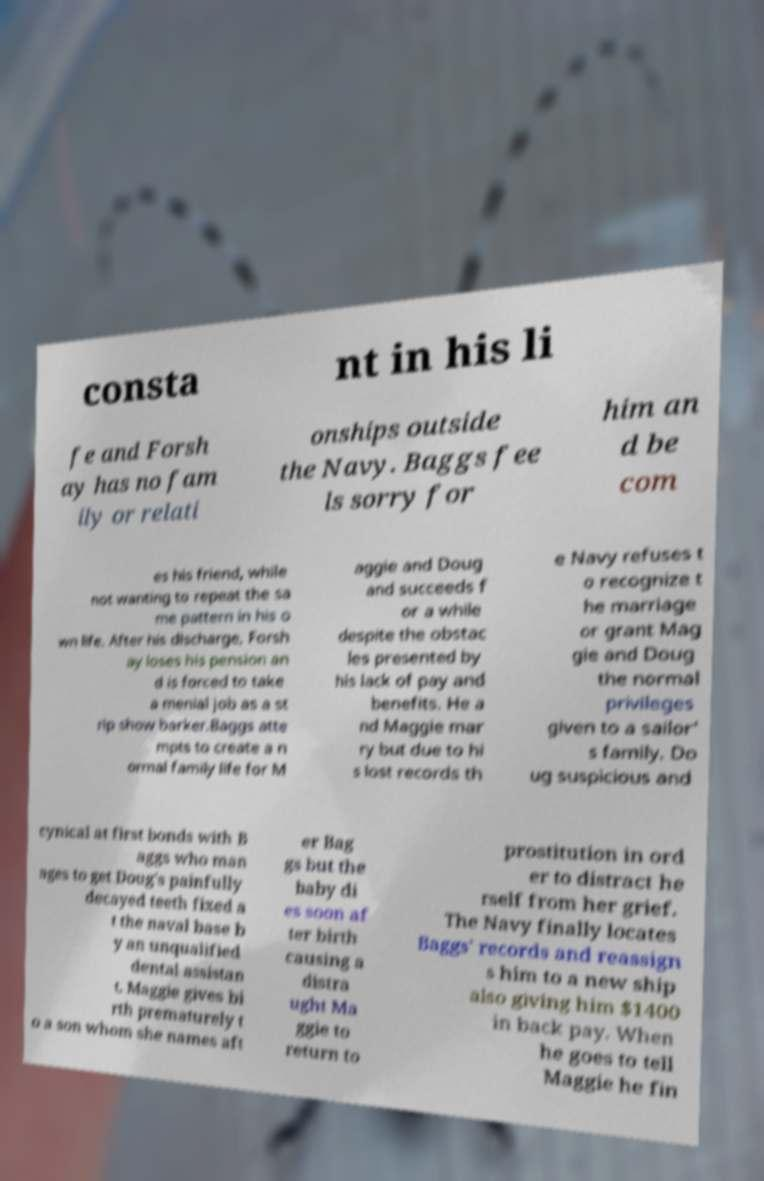Can you read and provide the text displayed in the image?This photo seems to have some interesting text. Can you extract and type it out for me? consta nt in his li fe and Forsh ay has no fam ily or relati onships outside the Navy. Baggs fee ls sorry for him an d be com es his friend, while not wanting to repeat the sa me pattern in his o wn life. After his discharge, Forsh ay loses his pension an d is forced to take a menial job as a st rip show barker.Baggs atte mpts to create a n ormal family life for M aggie and Doug and succeeds f or a while despite the obstac les presented by his lack of pay and benefits. He a nd Maggie mar ry but due to hi s lost records th e Navy refuses t o recognize t he marriage or grant Mag gie and Doug the normal privileges given to a sailor' s family. Do ug suspicious and cynical at first bonds with B aggs who man ages to get Doug's painfully decayed teeth fixed a t the naval base b y an unqualified dental assistan t. Maggie gives bi rth prematurely t o a son whom she names aft er Bag gs but the baby di es soon af ter birth causing a distra ught Ma ggie to return to prostitution in ord er to distract he rself from her grief. The Navy finally locates Baggs' records and reassign s him to a new ship also giving him $1400 in back pay. When he goes to tell Maggie he fin 